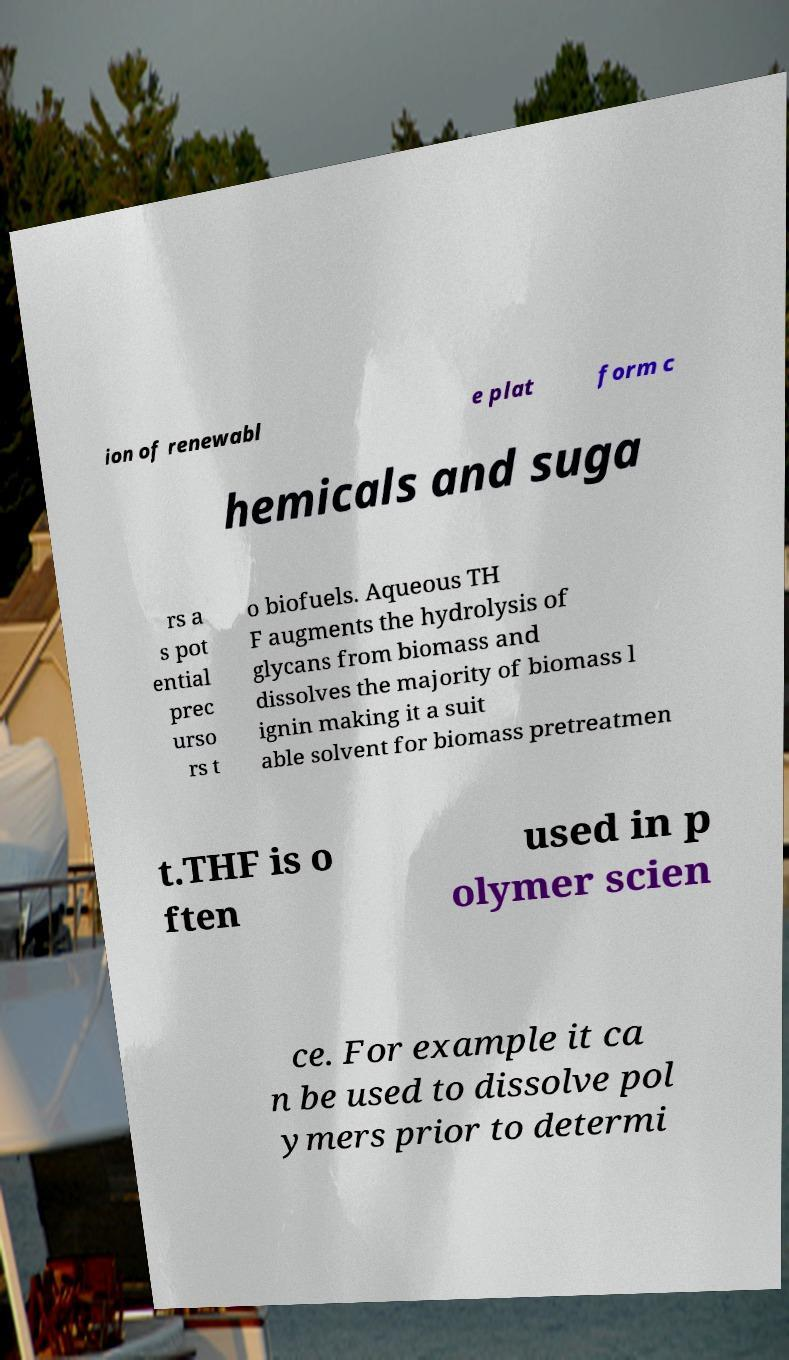Could you assist in decoding the text presented in this image and type it out clearly? ion of renewabl e plat form c hemicals and suga rs a s pot ential prec urso rs t o biofuels. Aqueous TH F augments the hydrolysis of glycans from biomass and dissolves the majority of biomass l ignin making it a suit able solvent for biomass pretreatmen t.THF is o ften used in p olymer scien ce. For example it ca n be used to dissolve pol ymers prior to determi 